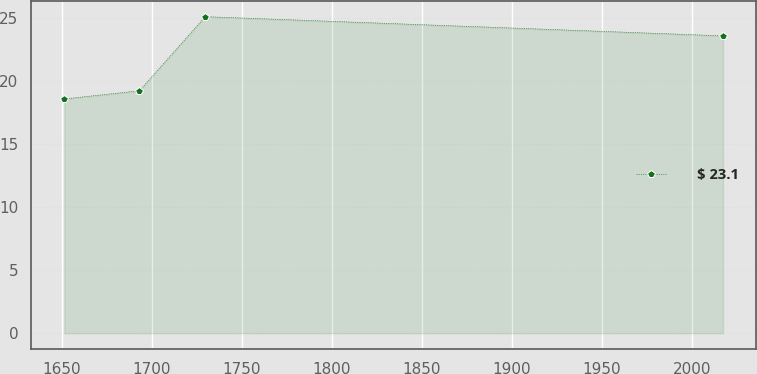<chart> <loc_0><loc_0><loc_500><loc_500><line_chart><ecel><fcel>$ 23.1<nl><fcel>1651.46<fcel>18.56<nl><fcel>1693.14<fcel>19.21<nl><fcel>1729.72<fcel>25.08<nl><fcel>2017.23<fcel>23.56<nl></chart> 